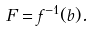Convert formula to latex. <formula><loc_0><loc_0><loc_500><loc_500>F = f ^ { - 1 } ( b ) .</formula> 